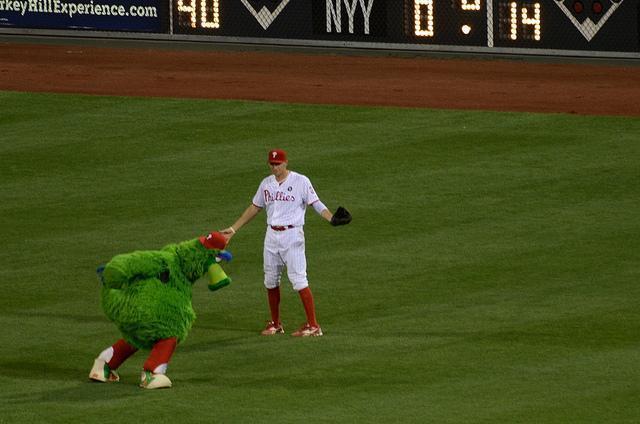How many kites do you see?
Give a very brief answer. 0. 